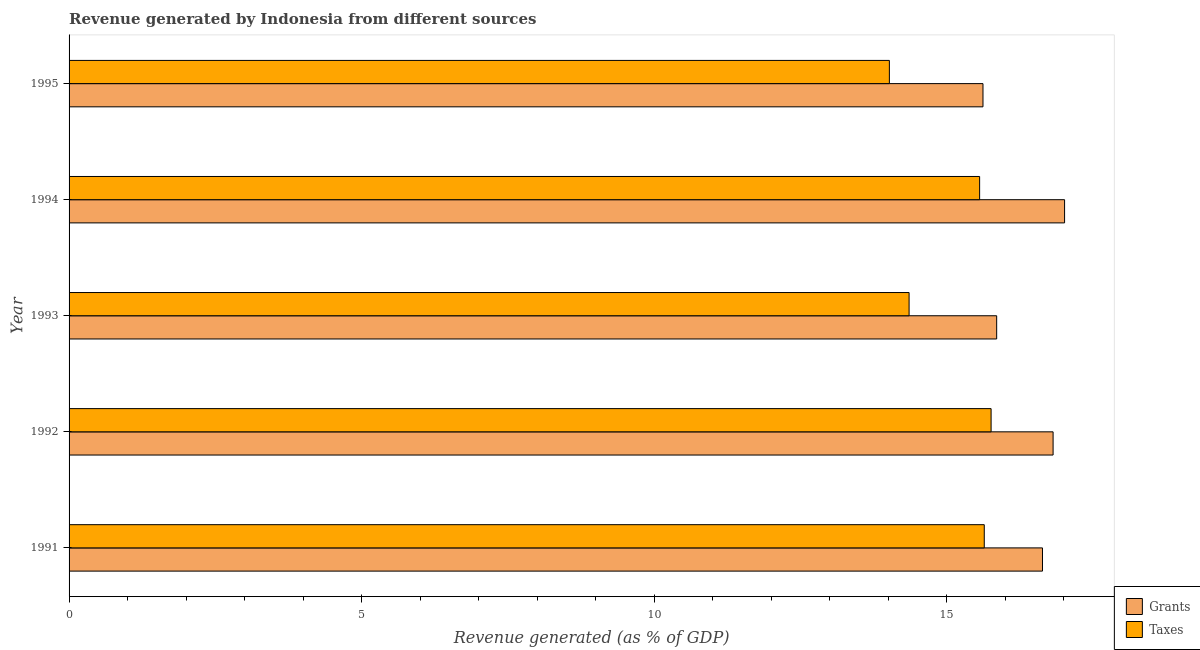How many different coloured bars are there?
Make the answer very short. 2. How many groups of bars are there?
Give a very brief answer. 5. Are the number of bars per tick equal to the number of legend labels?
Ensure brevity in your answer.  Yes. Are the number of bars on each tick of the Y-axis equal?
Provide a short and direct response. Yes. How many bars are there on the 2nd tick from the top?
Offer a terse response. 2. What is the label of the 3rd group of bars from the top?
Provide a succinct answer. 1993. What is the revenue generated by grants in 1994?
Make the answer very short. 17.01. Across all years, what is the maximum revenue generated by taxes?
Offer a very short reply. 15.76. Across all years, what is the minimum revenue generated by grants?
Your answer should be very brief. 15.62. What is the total revenue generated by grants in the graph?
Ensure brevity in your answer.  81.94. What is the difference between the revenue generated by taxes in 1994 and that in 1995?
Provide a short and direct response. 1.54. What is the difference between the revenue generated by taxes in 1995 and the revenue generated by grants in 1994?
Provide a short and direct response. -2.99. What is the average revenue generated by taxes per year?
Make the answer very short. 15.07. In the year 1994, what is the difference between the revenue generated by grants and revenue generated by taxes?
Your response must be concise. 1.45. In how many years, is the revenue generated by taxes greater than 5 %?
Give a very brief answer. 5. What is the ratio of the revenue generated by grants in 1993 to that in 1995?
Offer a very short reply. 1.01. Is the revenue generated by grants in 1992 less than that in 1994?
Provide a short and direct response. Yes. What is the difference between the highest and the second highest revenue generated by taxes?
Provide a succinct answer. 0.12. What is the difference between the highest and the lowest revenue generated by taxes?
Your answer should be very brief. 1.74. What does the 1st bar from the top in 1994 represents?
Your response must be concise. Taxes. What does the 2nd bar from the bottom in 1995 represents?
Offer a very short reply. Taxes. How many bars are there?
Offer a very short reply. 10. Are all the bars in the graph horizontal?
Give a very brief answer. Yes. Does the graph contain any zero values?
Your response must be concise. No. Does the graph contain grids?
Give a very brief answer. No. Where does the legend appear in the graph?
Keep it short and to the point. Bottom right. How many legend labels are there?
Make the answer very short. 2. How are the legend labels stacked?
Give a very brief answer. Vertical. What is the title of the graph?
Provide a short and direct response. Revenue generated by Indonesia from different sources. What is the label or title of the X-axis?
Your response must be concise. Revenue generated (as % of GDP). What is the Revenue generated (as % of GDP) of Grants in 1991?
Provide a succinct answer. 16.64. What is the Revenue generated (as % of GDP) in Taxes in 1991?
Offer a terse response. 15.64. What is the Revenue generated (as % of GDP) in Grants in 1992?
Keep it short and to the point. 16.82. What is the Revenue generated (as % of GDP) of Taxes in 1992?
Keep it short and to the point. 15.76. What is the Revenue generated (as % of GDP) in Grants in 1993?
Offer a very short reply. 15.85. What is the Revenue generated (as % of GDP) in Taxes in 1993?
Give a very brief answer. 14.36. What is the Revenue generated (as % of GDP) in Grants in 1994?
Ensure brevity in your answer.  17.01. What is the Revenue generated (as % of GDP) in Taxes in 1994?
Your answer should be very brief. 15.56. What is the Revenue generated (as % of GDP) of Grants in 1995?
Offer a very short reply. 15.62. What is the Revenue generated (as % of GDP) of Taxes in 1995?
Keep it short and to the point. 14.02. Across all years, what is the maximum Revenue generated (as % of GDP) of Grants?
Offer a terse response. 17.01. Across all years, what is the maximum Revenue generated (as % of GDP) of Taxes?
Make the answer very short. 15.76. Across all years, what is the minimum Revenue generated (as % of GDP) in Grants?
Offer a terse response. 15.62. Across all years, what is the minimum Revenue generated (as % of GDP) in Taxes?
Offer a very short reply. 14.02. What is the total Revenue generated (as % of GDP) of Grants in the graph?
Give a very brief answer. 81.94. What is the total Revenue generated (as % of GDP) in Taxes in the graph?
Offer a terse response. 75.34. What is the difference between the Revenue generated (as % of GDP) of Grants in 1991 and that in 1992?
Provide a short and direct response. -0.18. What is the difference between the Revenue generated (as % of GDP) of Taxes in 1991 and that in 1992?
Your answer should be compact. -0.12. What is the difference between the Revenue generated (as % of GDP) of Grants in 1991 and that in 1993?
Your answer should be very brief. 0.78. What is the difference between the Revenue generated (as % of GDP) in Taxes in 1991 and that in 1993?
Your answer should be compact. 1.28. What is the difference between the Revenue generated (as % of GDP) in Grants in 1991 and that in 1994?
Your answer should be compact. -0.38. What is the difference between the Revenue generated (as % of GDP) of Taxes in 1991 and that in 1994?
Provide a short and direct response. 0.08. What is the difference between the Revenue generated (as % of GDP) of Grants in 1991 and that in 1995?
Provide a succinct answer. 1.02. What is the difference between the Revenue generated (as % of GDP) in Taxes in 1991 and that in 1995?
Your answer should be very brief. 1.62. What is the difference between the Revenue generated (as % of GDP) of Grants in 1992 and that in 1993?
Provide a succinct answer. 0.96. What is the difference between the Revenue generated (as % of GDP) in Taxes in 1992 and that in 1993?
Ensure brevity in your answer.  1.4. What is the difference between the Revenue generated (as % of GDP) of Grants in 1992 and that in 1994?
Your answer should be compact. -0.2. What is the difference between the Revenue generated (as % of GDP) in Taxes in 1992 and that in 1994?
Keep it short and to the point. 0.2. What is the difference between the Revenue generated (as % of GDP) in Grants in 1992 and that in 1995?
Keep it short and to the point. 1.2. What is the difference between the Revenue generated (as % of GDP) of Taxes in 1992 and that in 1995?
Your response must be concise. 1.74. What is the difference between the Revenue generated (as % of GDP) in Grants in 1993 and that in 1994?
Your response must be concise. -1.16. What is the difference between the Revenue generated (as % of GDP) of Taxes in 1993 and that in 1994?
Ensure brevity in your answer.  -1.21. What is the difference between the Revenue generated (as % of GDP) of Grants in 1993 and that in 1995?
Give a very brief answer. 0.23. What is the difference between the Revenue generated (as % of GDP) of Taxes in 1993 and that in 1995?
Offer a terse response. 0.34. What is the difference between the Revenue generated (as % of GDP) of Grants in 1994 and that in 1995?
Ensure brevity in your answer.  1.39. What is the difference between the Revenue generated (as % of GDP) in Taxes in 1994 and that in 1995?
Make the answer very short. 1.54. What is the difference between the Revenue generated (as % of GDP) in Grants in 1991 and the Revenue generated (as % of GDP) in Taxes in 1992?
Ensure brevity in your answer.  0.88. What is the difference between the Revenue generated (as % of GDP) in Grants in 1991 and the Revenue generated (as % of GDP) in Taxes in 1993?
Keep it short and to the point. 2.28. What is the difference between the Revenue generated (as % of GDP) in Grants in 1991 and the Revenue generated (as % of GDP) in Taxes in 1994?
Provide a succinct answer. 1.07. What is the difference between the Revenue generated (as % of GDP) of Grants in 1991 and the Revenue generated (as % of GDP) of Taxes in 1995?
Provide a short and direct response. 2.62. What is the difference between the Revenue generated (as % of GDP) in Grants in 1992 and the Revenue generated (as % of GDP) in Taxes in 1993?
Your answer should be very brief. 2.46. What is the difference between the Revenue generated (as % of GDP) in Grants in 1992 and the Revenue generated (as % of GDP) in Taxes in 1994?
Your answer should be compact. 1.26. What is the difference between the Revenue generated (as % of GDP) of Grants in 1992 and the Revenue generated (as % of GDP) of Taxes in 1995?
Offer a terse response. 2.8. What is the difference between the Revenue generated (as % of GDP) in Grants in 1993 and the Revenue generated (as % of GDP) in Taxes in 1994?
Offer a very short reply. 0.29. What is the difference between the Revenue generated (as % of GDP) of Grants in 1993 and the Revenue generated (as % of GDP) of Taxes in 1995?
Offer a terse response. 1.83. What is the difference between the Revenue generated (as % of GDP) in Grants in 1994 and the Revenue generated (as % of GDP) in Taxes in 1995?
Offer a terse response. 2.99. What is the average Revenue generated (as % of GDP) of Grants per year?
Give a very brief answer. 16.39. What is the average Revenue generated (as % of GDP) in Taxes per year?
Offer a very short reply. 15.07. In the year 1991, what is the difference between the Revenue generated (as % of GDP) in Grants and Revenue generated (as % of GDP) in Taxes?
Provide a short and direct response. 0.99. In the year 1992, what is the difference between the Revenue generated (as % of GDP) of Grants and Revenue generated (as % of GDP) of Taxes?
Give a very brief answer. 1.06. In the year 1993, what is the difference between the Revenue generated (as % of GDP) in Grants and Revenue generated (as % of GDP) in Taxes?
Your response must be concise. 1.5. In the year 1994, what is the difference between the Revenue generated (as % of GDP) in Grants and Revenue generated (as % of GDP) in Taxes?
Ensure brevity in your answer.  1.45. What is the ratio of the Revenue generated (as % of GDP) of Grants in 1991 to that in 1992?
Ensure brevity in your answer.  0.99. What is the ratio of the Revenue generated (as % of GDP) of Taxes in 1991 to that in 1992?
Offer a very short reply. 0.99. What is the ratio of the Revenue generated (as % of GDP) in Grants in 1991 to that in 1993?
Your answer should be compact. 1.05. What is the ratio of the Revenue generated (as % of GDP) in Taxes in 1991 to that in 1993?
Offer a very short reply. 1.09. What is the ratio of the Revenue generated (as % of GDP) in Grants in 1991 to that in 1994?
Your response must be concise. 0.98. What is the ratio of the Revenue generated (as % of GDP) of Taxes in 1991 to that in 1994?
Ensure brevity in your answer.  1.01. What is the ratio of the Revenue generated (as % of GDP) of Grants in 1991 to that in 1995?
Give a very brief answer. 1.07. What is the ratio of the Revenue generated (as % of GDP) in Taxes in 1991 to that in 1995?
Your response must be concise. 1.12. What is the ratio of the Revenue generated (as % of GDP) of Grants in 1992 to that in 1993?
Give a very brief answer. 1.06. What is the ratio of the Revenue generated (as % of GDP) of Taxes in 1992 to that in 1993?
Keep it short and to the point. 1.1. What is the ratio of the Revenue generated (as % of GDP) in Grants in 1992 to that in 1994?
Offer a very short reply. 0.99. What is the ratio of the Revenue generated (as % of GDP) in Taxes in 1992 to that in 1994?
Make the answer very short. 1.01. What is the ratio of the Revenue generated (as % of GDP) in Grants in 1992 to that in 1995?
Give a very brief answer. 1.08. What is the ratio of the Revenue generated (as % of GDP) in Taxes in 1992 to that in 1995?
Offer a terse response. 1.12. What is the ratio of the Revenue generated (as % of GDP) in Grants in 1993 to that in 1994?
Give a very brief answer. 0.93. What is the ratio of the Revenue generated (as % of GDP) in Taxes in 1993 to that in 1994?
Ensure brevity in your answer.  0.92. What is the ratio of the Revenue generated (as % of GDP) of Grants in 1994 to that in 1995?
Offer a terse response. 1.09. What is the ratio of the Revenue generated (as % of GDP) of Taxes in 1994 to that in 1995?
Offer a very short reply. 1.11. What is the difference between the highest and the second highest Revenue generated (as % of GDP) in Grants?
Provide a succinct answer. 0.2. What is the difference between the highest and the second highest Revenue generated (as % of GDP) in Taxes?
Provide a short and direct response. 0.12. What is the difference between the highest and the lowest Revenue generated (as % of GDP) in Grants?
Your answer should be very brief. 1.39. What is the difference between the highest and the lowest Revenue generated (as % of GDP) in Taxes?
Make the answer very short. 1.74. 